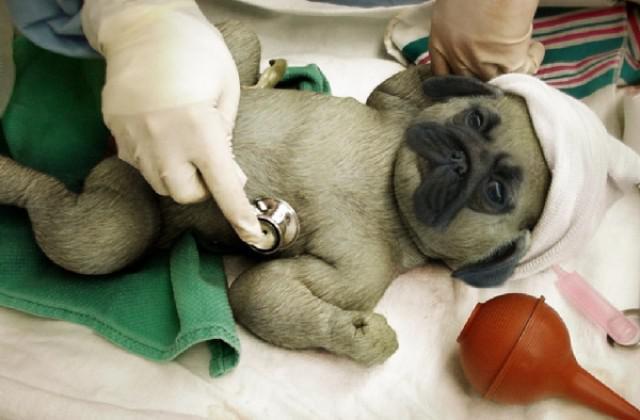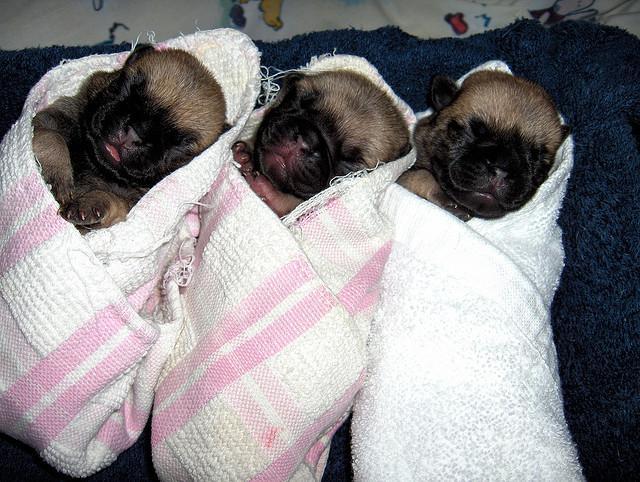The first image is the image on the left, the second image is the image on the right. For the images shown, is this caption "Two baby animals with tiger stripes are nursing a reclining pug dog in one image." true? Answer yes or no. No. The first image is the image on the left, the second image is the image on the right. Analyze the images presented: Is the assertion "Two striped cats are nursing on a dog in one of the images." valid? Answer yes or no. No. 